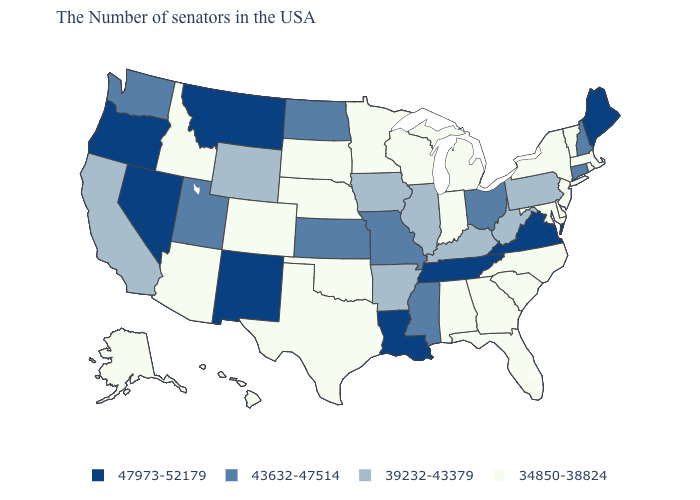Does Kansas have the lowest value in the MidWest?
Give a very brief answer. No. Among the states that border Oklahoma , which have the highest value?
Write a very short answer. New Mexico. What is the value of Mississippi?
Write a very short answer. 43632-47514. Which states have the lowest value in the Northeast?
Short answer required. Massachusetts, Rhode Island, Vermont, New York, New Jersey. What is the highest value in the MidWest ?
Answer briefly. 43632-47514. What is the value of Arkansas?
Be succinct. 39232-43379. Which states hav the highest value in the South?
Be succinct. Virginia, Tennessee, Louisiana. What is the value of Alaska?
Answer briefly. 34850-38824. What is the highest value in states that border Delaware?
Short answer required. 39232-43379. Does New Mexico have a higher value than Washington?
Be succinct. Yes. What is the value of Georgia?
Answer briefly. 34850-38824. What is the highest value in the South ?
Keep it brief. 47973-52179. Name the states that have a value in the range 34850-38824?
Give a very brief answer. Massachusetts, Rhode Island, Vermont, New York, New Jersey, Delaware, Maryland, North Carolina, South Carolina, Florida, Georgia, Michigan, Indiana, Alabama, Wisconsin, Minnesota, Nebraska, Oklahoma, Texas, South Dakota, Colorado, Arizona, Idaho, Alaska, Hawaii. Does Maine have the highest value in the Northeast?
Write a very short answer. Yes. What is the value of Hawaii?
Give a very brief answer. 34850-38824. 